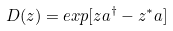Convert formula to latex. <formula><loc_0><loc_0><loc_500><loc_500>D ( z ) = e x p [ z a ^ { \dagger } - z ^ { * } a ]</formula> 